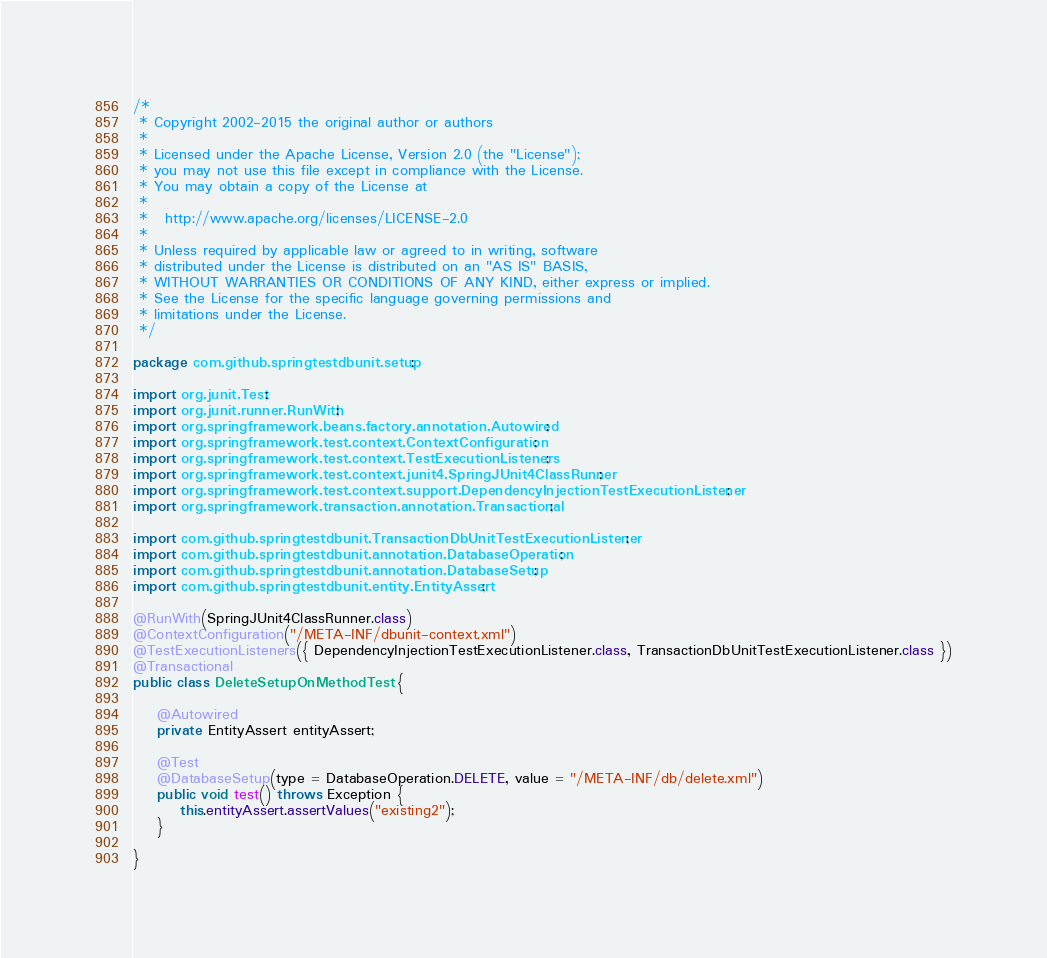<code> <loc_0><loc_0><loc_500><loc_500><_Java_>/*
 * Copyright 2002-2015 the original author or authors
 *
 * Licensed under the Apache License, Version 2.0 (the "License");
 * you may not use this file except in compliance with the License.
 * You may obtain a copy of the License at
 *
 *   http://www.apache.org/licenses/LICENSE-2.0
 *
 * Unless required by applicable law or agreed to in writing, software
 * distributed under the License is distributed on an "AS IS" BASIS,
 * WITHOUT WARRANTIES OR CONDITIONS OF ANY KIND, either express or implied.
 * See the License for the specific language governing permissions and
 * limitations under the License.
 */

package com.github.springtestdbunit.setup;

import org.junit.Test;
import org.junit.runner.RunWith;
import org.springframework.beans.factory.annotation.Autowired;
import org.springframework.test.context.ContextConfiguration;
import org.springframework.test.context.TestExecutionListeners;
import org.springframework.test.context.junit4.SpringJUnit4ClassRunner;
import org.springframework.test.context.support.DependencyInjectionTestExecutionListener;
import org.springframework.transaction.annotation.Transactional;

import com.github.springtestdbunit.TransactionDbUnitTestExecutionListener;
import com.github.springtestdbunit.annotation.DatabaseOperation;
import com.github.springtestdbunit.annotation.DatabaseSetup;
import com.github.springtestdbunit.entity.EntityAssert;

@RunWith(SpringJUnit4ClassRunner.class)
@ContextConfiguration("/META-INF/dbunit-context.xml")
@TestExecutionListeners({ DependencyInjectionTestExecutionListener.class, TransactionDbUnitTestExecutionListener.class })
@Transactional
public class DeleteSetupOnMethodTest {

	@Autowired
	private EntityAssert entityAssert;

	@Test
	@DatabaseSetup(type = DatabaseOperation.DELETE, value = "/META-INF/db/delete.xml")
	public void test() throws Exception {
		this.entityAssert.assertValues("existing2");
	}

}
</code> 